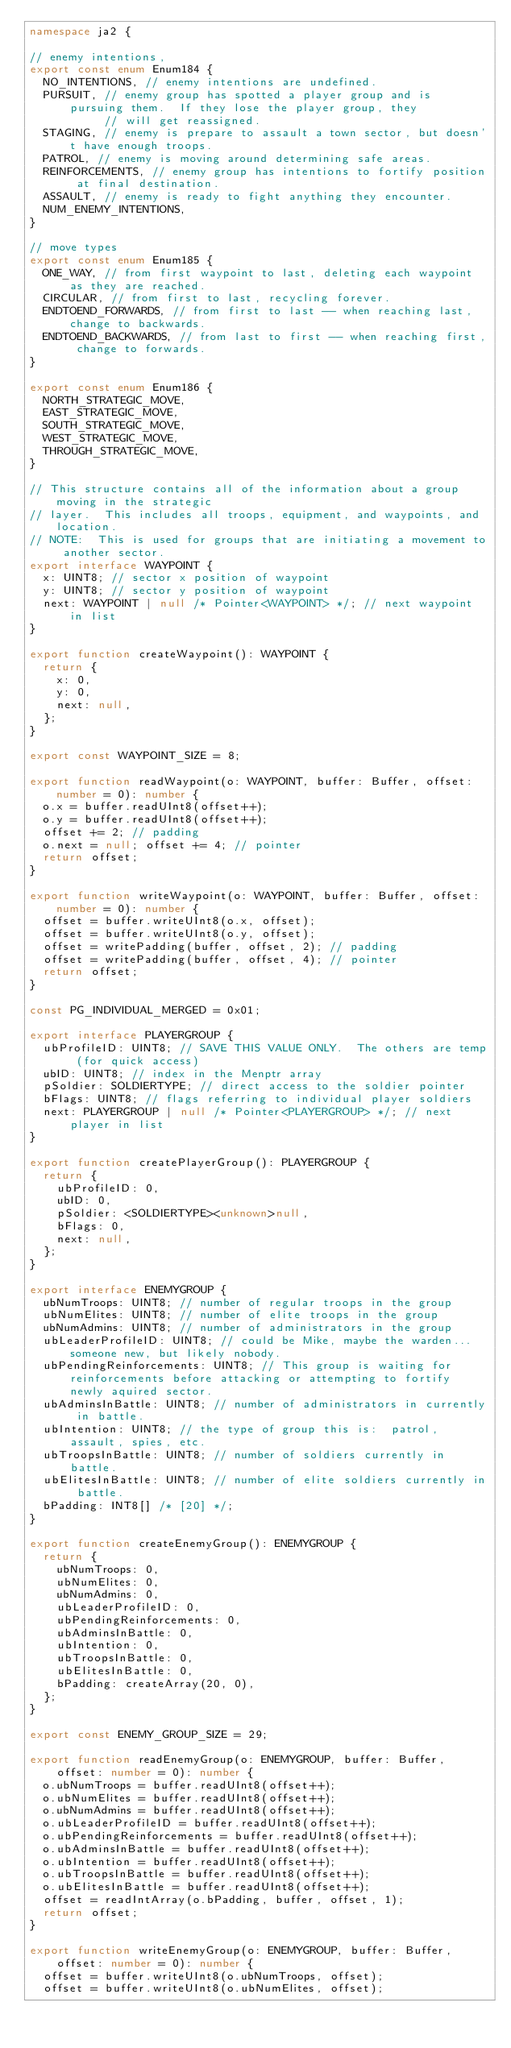Convert code to text. <code><loc_0><loc_0><loc_500><loc_500><_TypeScript_>namespace ja2 {

// enemy intentions,
export const enum Enum184 {
  NO_INTENTIONS, // enemy intentions are undefined.
  PURSUIT, // enemy group has spotted a player group and is pursuing them.  If they lose the player group, they
           // will get reassigned.
  STAGING, // enemy is prepare to assault a town sector, but doesn't have enough troops.
  PATROL, // enemy is moving around determining safe areas.
  REINFORCEMENTS, // enemy group has intentions to fortify position at final destination.
  ASSAULT, // enemy is ready to fight anything they encounter.
  NUM_ENEMY_INTENTIONS,
}

// move types
export const enum Enum185 {
  ONE_WAY, // from first waypoint to last, deleting each waypoint as they are reached.
  CIRCULAR, // from first to last, recycling forever.
  ENDTOEND_FORWARDS, // from first to last -- when reaching last, change to backwards.
  ENDTOEND_BACKWARDS, // from last to first -- when reaching first, change to forwards.
}

export const enum Enum186 {
  NORTH_STRATEGIC_MOVE,
  EAST_STRATEGIC_MOVE,
  SOUTH_STRATEGIC_MOVE,
  WEST_STRATEGIC_MOVE,
  THROUGH_STRATEGIC_MOVE,
}

// This structure contains all of the information about a group moving in the strategic
// layer.  This includes all troops, equipment, and waypoints, and location.
// NOTE:  This is used for groups that are initiating a movement to another sector.
export interface WAYPOINT {
  x: UINT8; // sector x position of waypoint
  y: UINT8; // sector y position of waypoint
  next: WAYPOINT | null /* Pointer<WAYPOINT> */; // next waypoint in list
}

export function createWaypoint(): WAYPOINT {
  return {
    x: 0,
    y: 0,
    next: null,
  };
}

export const WAYPOINT_SIZE = 8;

export function readWaypoint(o: WAYPOINT, buffer: Buffer, offset: number = 0): number {
  o.x = buffer.readUInt8(offset++);
  o.y = buffer.readUInt8(offset++);
  offset += 2; // padding
  o.next = null; offset += 4; // pointer
  return offset;
}

export function writeWaypoint(o: WAYPOINT, buffer: Buffer, offset: number = 0): number {
  offset = buffer.writeUInt8(o.x, offset);
  offset = buffer.writeUInt8(o.y, offset);
  offset = writePadding(buffer, offset, 2); // padding
  offset = writePadding(buffer, offset, 4); // pointer
  return offset;
}

const PG_INDIVIDUAL_MERGED = 0x01;

export interface PLAYERGROUP {
  ubProfileID: UINT8; // SAVE THIS VALUE ONLY.  The others are temp (for quick access)
  ubID: UINT8; // index in the Menptr array
  pSoldier: SOLDIERTYPE; // direct access to the soldier pointer
  bFlags: UINT8; // flags referring to individual player soldiers
  next: PLAYERGROUP | null /* Pointer<PLAYERGROUP> */; // next player in list
}

export function createPlayerGroup(): PLAYERGROUP {
  return {
    ubProfileID: 0,
    ubID: 0,
    pSoldier: <SOLDIERTYPE><unknown>null,
    bFlags: 0,
    next: null,
  };
}

export interface ENEMYGROUP {
  ubNumTroops: UINT8; // number of regular troops in the group
  ubNumElites: UINT8; // number of elite troops in the group
  ubNumAdmins: UINT8; // number of administrators in the group
  ubLeaderProfileID: UINT8; // could be Mike, maybe the warden... someone new, but likely nobody.
  ubPendingReinforcements: UINT8; // This group is waiting for reinforcements before attacking or attempting to fortify newly aquired sector.
  ubAdminsInBattle: UINT8; // number of administrators in currently in battle.
  ubIntention: UINT8; // the type of group this is:  patrol, assault, spies, etc.
  ubTroopsInBattle: UINT8; // number of soldiers currently in battle.
  ubElitesInBattle: UINT8; // number of elite soldiers currently in battle.
  bPadding: INT8[] /* [20] */;
}

export function createEnemyGroup(): ENEMYGROUP {
  return {
    ubNumTroops: 0,
    ubNumElites: 0,
    ubNumAdmins: 0,
    ubLeaderProfileID: 0,
    ubPendingReinforcements: 0,
    ubAdminsInBattle: 0,
    ubIntention: 0,
    ubTroopsInBattle: 0,
    ubElitesInBattle: 0,
    bPadding: createArray(20, 0),
  };
}

export const ENEMY_GROUP_SIZE = 29;

export function readEnemyGroup(o: ENEMYGROUP, buffer: Buffer, offset: number = 0): number {
  o.ubNumTroops = buffer.readUInt8(offset++);
  o.ubNumElites = buffer.readUInt8(offset++);
  o.ubNumAdmins = buffer.readUInt8(offset++);
  o.ubLeaderProfileID = buffer.readUInt8(offset++);
  o.ubPendingReinforcements = buffer.readUInt8(offset++);
  o.ubAdminsInBattle = buffer.readUInt8(offset++);
  o.ubIntention = buffer.readUInt8(offset++);
  o.ubTroopsInBattle = buffer.readUInt8(offset++);
  o.ubElitesInBattle = buffer.readUInt8(offset++);
  offset = readIntArray(o.bPadding, buffer, offset, 1);
  return offset;
}

export function writeEnemyGroup(o: ENEMYGROUP, buffer: Buffer, offset: number = 0): number {
  offset = buffer.writeUInt8(o.ubNumTroops, offset);
  offset = buffer.writeUInt8(o.ubNumElites, offset);</code> 